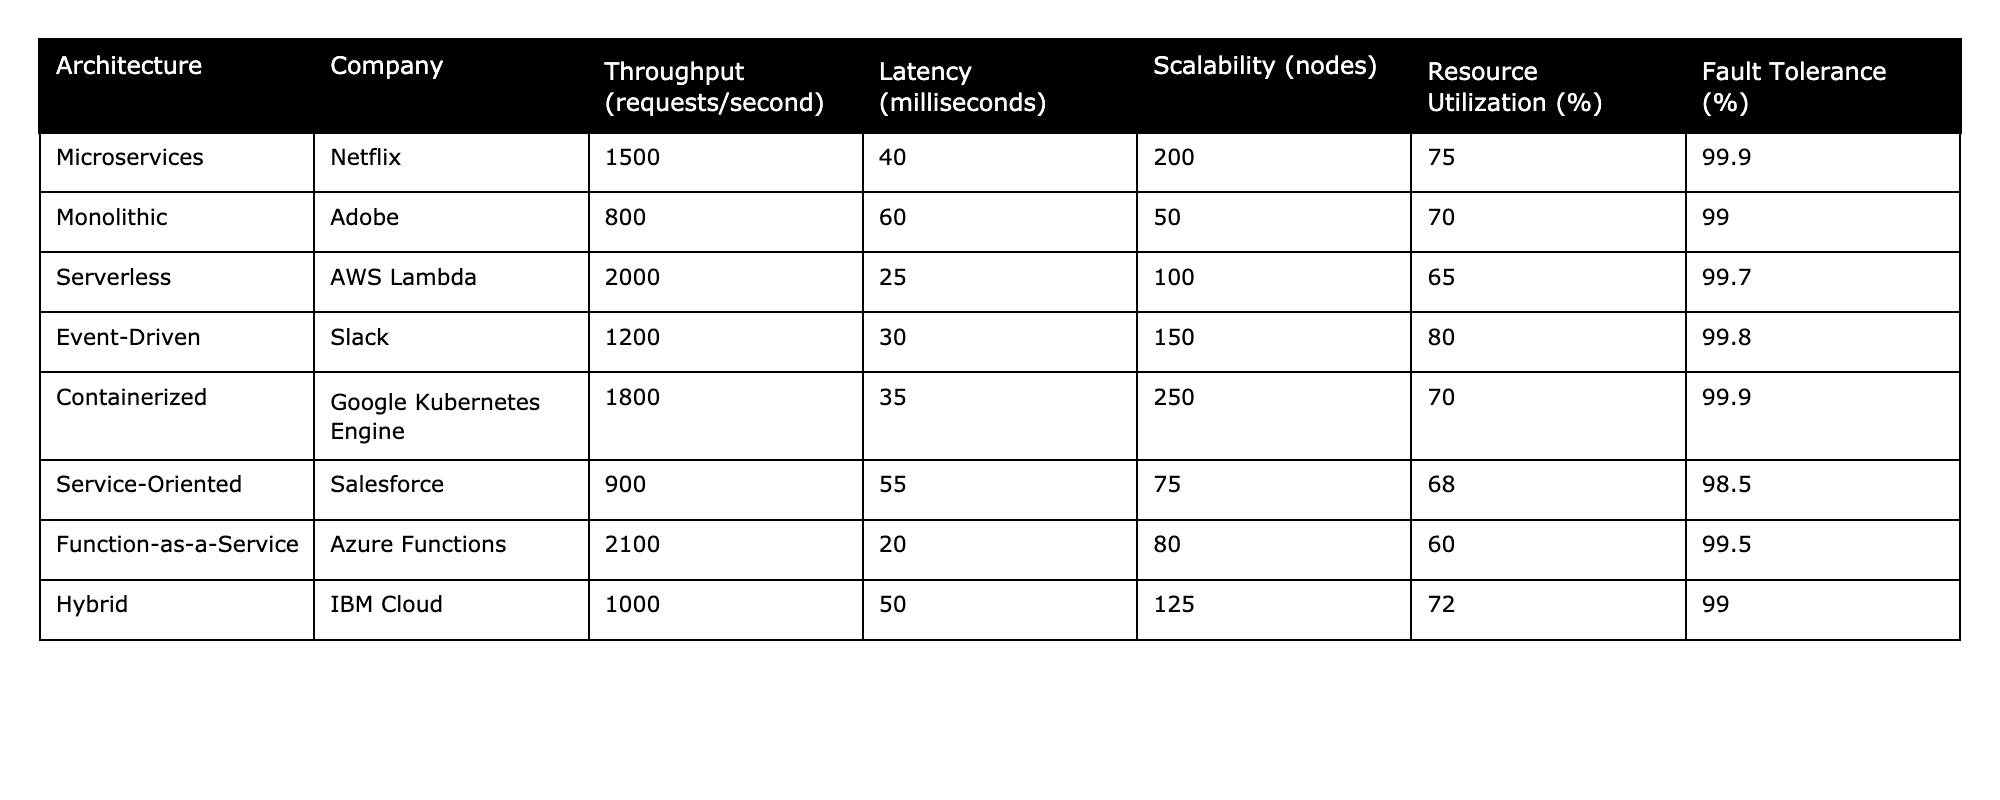What is the throughput of the Serverless architecture provided by AWS Lambda? The table lists the value for the throughput specifically under the Serverless architecture row, which shows a throughput of 2000 requests per second.
Answer: 2000 Which architecture has the lowest latency according to the table? By reviewing the Latency column in the table, I observe that the Function-as-a-Service architecture has the lowest latency, recorded at 20 milliseconds.
Answer: Function-as-a-Service What is the average scalability (in nodes) of all architectures listed? To find the average scalability, I will sum the scalability values (200 + 50 + 100 + 150 + 250 + 75 + 80 + 125 = 1030) and divide by the number of architectures (8). Thus, 1030 / 8 = 128.75.
Answer: 128.75 Is the Fault Tolerance of the Hybrid architecture less than 99%? Looking at the Fault Tolerance column, the Hybrid architecture has a Fault Tolerance of 99%, which is not less than 99%.
Answer: No What is the resource utilization of the Microservices architecture, and how does it compare to the average of all architectures? The Resource Utilization for Microservices is 75%. To find the average, I sum all the values under Resource Utilization (75 + 70 + 65 + 80 + 70 + 68 + 60 + 72 = 590) and divide by 8 (590 / 8 = 73.75). Since 75 is greater than 73.75, Microservices has higher Resource Utilization than the average.
Answer: Yes, it is higher Which architecture has the highest throughput and what is its value? The Throughput column indicates the Function-as-a-Service architecture has the highest throughput, at a value of 2100 requests per second.
Answer: Function-as-a-Service, 2100 Are there any architectures with a Fault Tolerance rating of over 99.5%? Cross-referencing the Fault Tolerance column shows that both the Microservices and Containerized architectures meet this criterion with ratings of 99.9%.
Answer: Yes What is the difference in latency between the Serverless and Event-Driven architectures? The Latency for Serverless is 25 milliseconds and for Event-Driven is 30 milliseconds. The difference is calculated by subtracting these values: 30 - 25 = 5 milliseconds.
Answer: 5 milliseconds Which architecture shows the best performance in terms of both Throughput and Latency? To identify the best architecture, I compare the Throughput and Latency values. The Function-as-a-Service, while highest in throughput (2100 requests/second), has the lowest latency (20 ms), thus performing best overall in these metrics.
Answer: Function-as-a-Service 